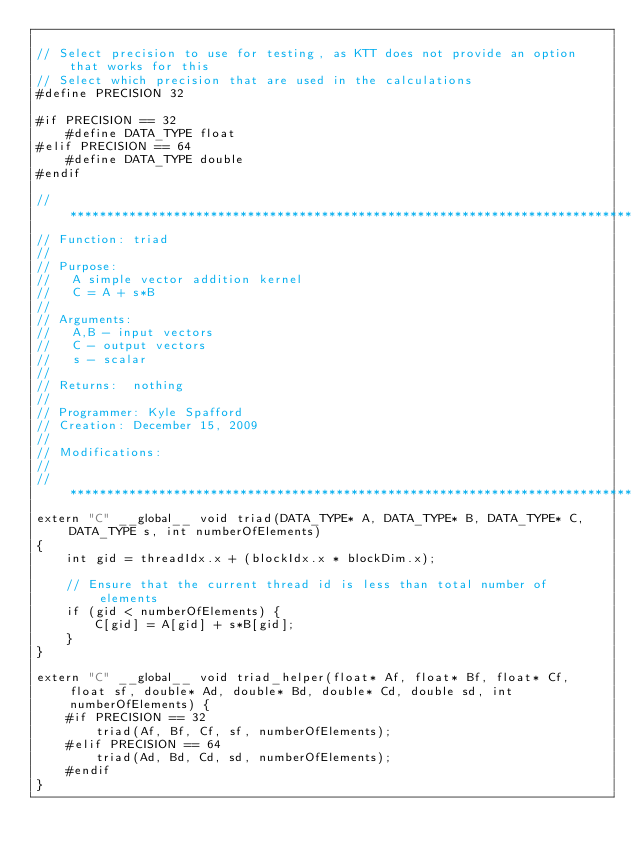<code> <loc_0><loc_0><loc_500><loc_500><_Cuda_>
// Select precision to use for testing, as KTT does not provide an option that works for this
// Select which precision that are used in the calculations
#define PRECISION 32

#if PRECISION == 32
    #define DATA_TYPE float
#elif PRECISION == 64
    #define DATA_TYPE double
#endif

// ****************************************************************************
// Function: triad
//
// Purpose:
//   A simple vector addition kernel
//   C = A + s*B
//
// Arguments:
//   A,B - input vectors
//   C - output vectors
//   s - scalar
//
// Returns:  nothing
//
// Programmer: Kyle Spafford
// Creation: December 15, 2009
//
// Modifications:
//
// ****************************************************************************
extern "C" __global__ void triad(DATA_TYPE* A, DATA_TYPE* B, DATA_TYPE* C, DATA_TYPE s, int numberOfElements)
{
    int gid = threadIdx.x + (blockIdx.x * blockDim.x);
    
    // Ensure that the current thread id is less than total number of elements
    if (gid < numberOfElements) {
        C[gid] = A[gid] + s*B[gid];
    }
}

extern "C" __global__ void triad_helper(float* Af, float* Bf, float* Cf, float sf, double* Ad, double* Bd, double* Cd, double sd, int numberOfElements) {
    #if PRECISION == 32
        triad(Af, Bf, Cf, sf, numberOfElements);
    #elif PRECISION == 64
        triad(Ad, Bd, Cd, sd, numberOfElements);
    #endif
}</code> 